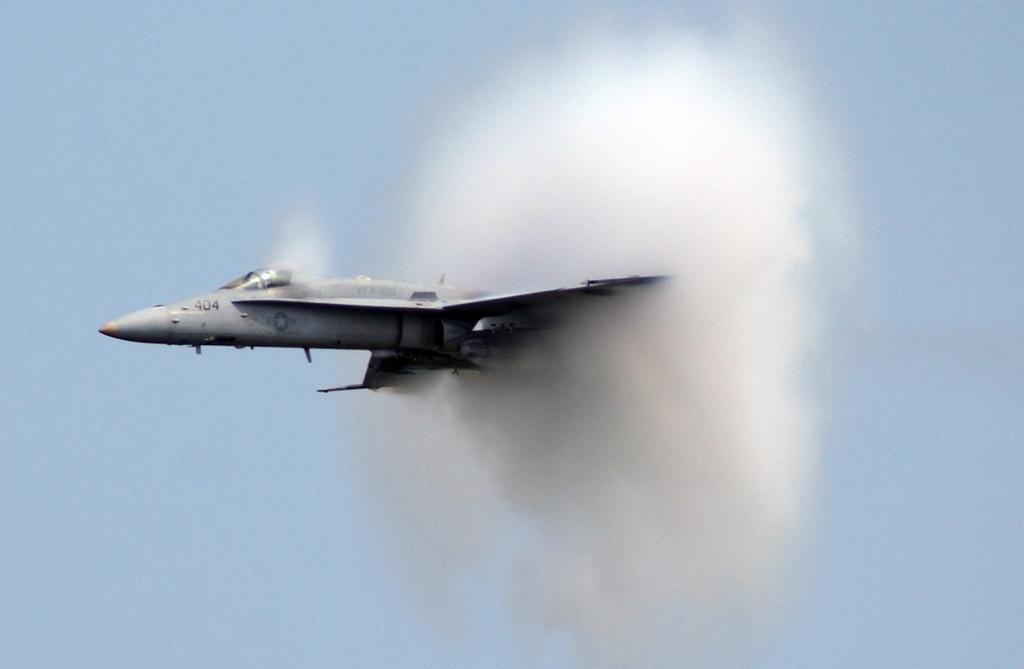What is the planes number?
Keep it short and to the point. 404. 